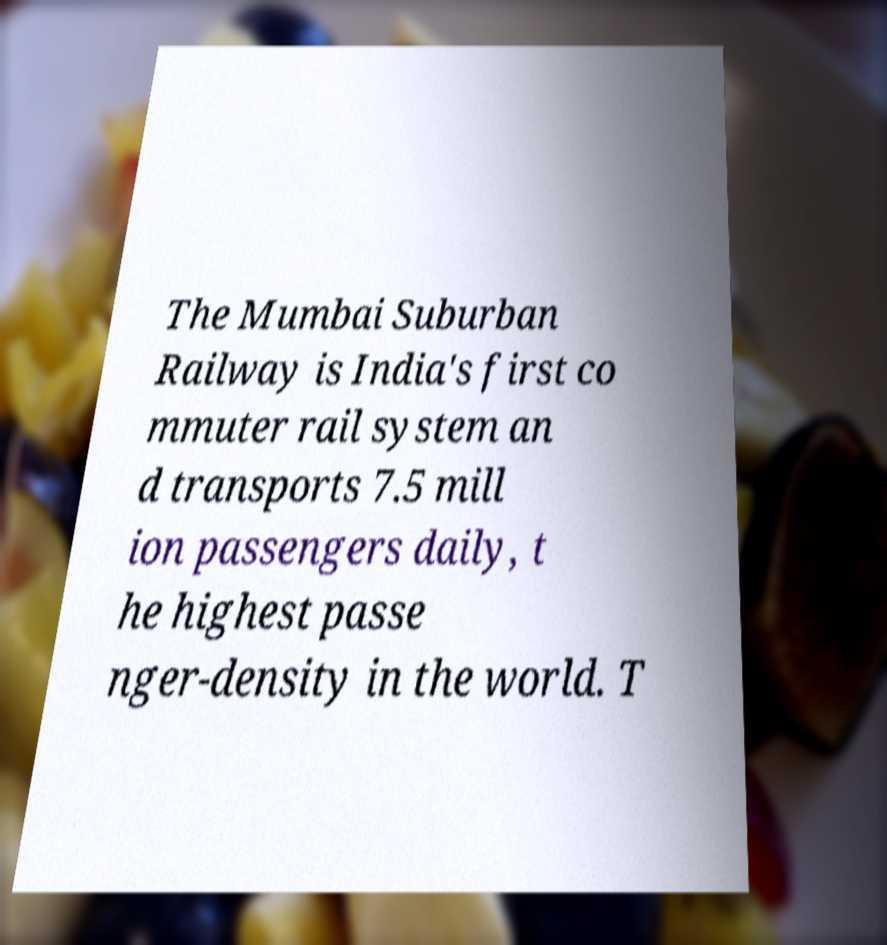What messages or text are displayed in this image? I need them in a readable, typed format. The Mumbai Suburban Railway is India's first co mmuter rail system an d transports 7.5 mill ion passengers daily, t he highest passe nger-density in the world. T 